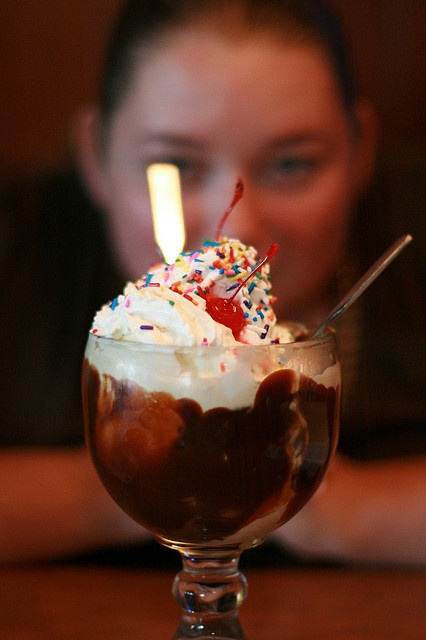Describe the objects in this image and their specific colors. I can see people in maroon, black, and brown tones, wine glass in maroon, black, darkgray, and tan tones, cup in maroon, black, darkgray, and lightgray tones, spoon in maroon, ivory, khaki, gray, and tan tones, and spoon in maroon, black, and brown tones in this image. 